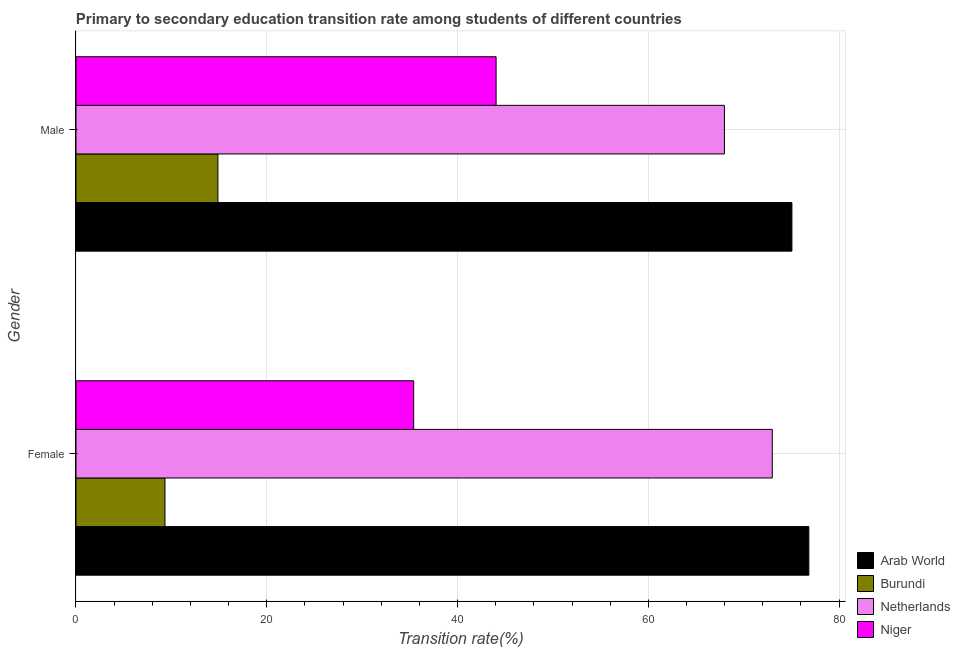Are the number of bars on each tick of the Y-axis equal?
Make the answer very short. Yes. What is the transition rate among male students in Niger?
Your answer should be very brief. 44.04. Across all countries, what is the maximum transition rate among female students?
Provide a short and direct response. 76.83. Across all countries, what is the minimum transition rate among male students?
Ensure brevity in your answer.  14.88. In which country was the transition rate among female students maximum?
Provide a short and direct response. Arab World. In which country was the transition rate among female students minimum?
Offer a very short reply. Burundi. What is the total transition rate among female students in the graph?
Offer a very short reply. 194.55. What is the difference between the transition rate among female students in Arab World and that in Netherlands?
Ensure brevity in your answer.  3.83. What is the difference between the transition rate among male students in Netherlands and the transition rate among female students in Burundi?
Your response must be concise. 58.65. What is the average transition rate among male students per country?
Provide a short and direct response. 50.49. What is the difference between the transition rate among male students and transition rate among female students in Niger?
Ensure brevity in your answer.  8.64. In how many countries, is the transition rate among male students greater than 44 %?
Make the answer very short. 3. What is the ratio of the transition rate among female students in Arab World to that in Netherlands?
Keep it short and to the point. 1.05. What does the 3rd bar from the top in Female represents?
Your answer should be very brief. Burundi. Are all the bars in the graph horizontal?
Give a very brief answer. Yes. How many countries are there in the graph?
Your answer should be very brief. 4. What is the difference between two consecutive major ticks on the X-axis?
Offer a terse response. 20. Does the graph contain grids?
Give a very brief answer. Yes. Where does the legend appear in the graph?
Provide a short and direct response. Bottom right. How many legend labels are there?
Your answer should be compact. 4. How are the legend labels stacked?
Provide a succinct answer. Vertical. What is the title of the graph?
Provide a succinct answer. Primary to secondary education transition rate among students of different countries. Does "Malta" appear as one of the legend labels in the graph?
Your response must be concise. No. What is the label or title of the X-axis?
Your response must be concise. Transition rate(%). What is the Transition rate(%) of Arab World in Female?
Offer a terse response. 76.83. What is the Transition rate(%) of Burundi in Female?
Keep it short and to the point. 9.33. What is the Transition rate(%) of Netherlands in Female?
Keep it short and to the point. 73. What is the Transition rate(%) in Niger in Female?
Your answer should be compact. 35.4. What is the Transition rate(%) of Arab World in Male?
Your response must be concise. 75.05. What is the Transition rate(%) of Burundi in Male?
Provide a short and direct response. 14.88. What is the Transition rate(%) in Netherlands in Male?
Your response must be concise. 67.98. What is the Transition rate(%) in Niger in Male?
Your response must be concise. 44.04. Across all Gender, what is the maximum Transition rate(%) of Arab World?
Offer a terse response. 76.83. Across all Gender, what is the maximum Transition rate(%) in Burundi?
Your answer should be very brief. 14.88. Across all Gender, what is the maximum Transition rate(%) in Netherlands?
Your answer should be compact. 73. Across all Gender, what is the maximum Transition rate(%) of Niger?
Offer a very short reply. 44.04. Across all Gender, what is the minimum Transition rate(%) of Arab World?
Offer a terse response. 75.05. Across all Gender, what is the minimum Transition rate(%) of Burundi?
Your response must be concise. 9.33. Across all Gender, what is the minimum Transition rate(%) in Netherlands?
Offer a terse response. 67.98. Across all Gender, what is the minimum Transition rate(%) in Niger?
Your answer should be compact. 35.4. What is the total Transition rate(%) of Arab World in the graph?
Ensure brevity in your answer.  151.88. What is the total Transition rate(%) in Burundi in the graph?
Make the answer very short. 24.21. What is the total Transition rate(%) in Netherlands in the graph?
Your response must be concise. 140.97. What is the total Transition rate(%) of Niger in the graph?
Provide a succinct answer. 79.44. What is the difference between the Transition rate(%) of Arab World in Female and that in Male?
Offer a terse response. 1.78. What is the difference between the Transition rate(%) of Burundi in Female and that in Male?
Keep it short and to the point. -5.55. What is the difference between the Transition rate(%) of Netherlands in Female and that in Male?
Your response must be concise. 5.02. What is the difference between the Transition rate(%) of Niger in Female and that in Male?
Offer a very short reply. -8.64. What is the difference between the Transition rate(%) in Arab World in Female and the Transition rate(%) in Burundi in Male?
Your response must be concise. 61.95. What is the difference between the Transition rate(%) of Arab World in Female and the Transition rate(%) of Netherlands in Male?
Offer a very short reply. 8.85. What is the difference between the Transition rate(%) of Arab World in Female and the Transition rate(%) of Niger in Male?
Your response must be concise. 32.79. What is the difference between the Transition rate(%) in Burundi in Female and the Transition rate(%) in Netherlands in Male?
Your answer should be very brief. -58.65. What is the difference between the Transition rate(%) in Burundi in Female and the Transition rate(%) in Niger in Male?
Provide a short and direct response. -34.71. What is the difference between the Transition rate(%) in Netherlands in Female and the Transition rate(%) in Niger in Male?
Ensure brevity in your answer.  28.95. What is the average Transition rate(%) in Arab World per Gender?
Offer a very short reply. 75.94. What is the average Transition rate(%) in Burundi per Gender?
Your response must be concise. 12.1. What is the average Transition rate(%) of Netherlands per Gender?
Offer a terse response. 70.49. What is the average Transition rate(%) of Niger per Gender?
Your answer should be compact. 39.72. What is the difference between the Transition rate(%) in Arab World and Transition rate(%) in Burundi in Female?
Give a very brief answer. 67.5. What is the difference between the Transition rate(%) in Arab World and Transition rate(%) in Netherlands in Female?
Your response must be concise. 3.83. What is the difference between the Transition rate(%) of Arab World and Transition rate(%) of Niger in Female?
Keep it short and to the point. 41.43. What is the difference between the Transition rate(%) in Burundi and Transition rate(%) in Netherlands in Female?
Offer a very short reply. -63.67. What is the difference between the Transition rate(%) of Burundi and Transition rate(%) of Niger in Female?
Provide a short and direct response. -26.07. What is the difference between the Transition rate(%) in Netherlands and Transition rate(%) in Niger in Female?
Your answer should be very brief. 37.59. What is the difference between the Transition rate(%) in Arab World and Transition rate(%) in Burundi in Male?
Keep it short and to the point. 60.17. What is the difference between the Transition rate(%) of Arab World and Transition rate(%) of Netherlands in Male?
Give a very brief answer. 7.08. What is the difference between the Transition rate(%) in Arab World and Transition rate(%) in Niger in Male?
Offer a terse response. 31.01. What is the difference between the Transition rate(%) in Burundi and Transition rate(%) in Netherlands in Male?
Keep it short and to the point. -53.1. What is the difference between the Transition rate(%) in Burundi and Transition rate(%) in Niger in Male?
Make the answer very short. -29.16. What is the difference between the Transition rate(%) of Netherlands and Transition rate(%) of Niger in Male?
Your response must be concise. 23.94. What is the ratio of the Transition rate(%) in Arab World in Female to that in Male?
Your answer should be very brief. 1.02. What is the ratio of the Transition rate(%) of Burundi in Female to that in Male?
Offer a terse response. 0.63. What is the ratio of the Transition rate(%) of Netherlands in Female to that in Male?
Provide a succinct answer. 1.07. What is the ratio of the Transition rate(%) in Niger in Female to that in Male?
Your answer should be very brief. 0.8. What is the difference between the highest and the second highest Transition rate(%) of Arab World?
Keep it short and to the point. 1.78. What is the difference between the highest and the second highest Transition rate(%) of Burundi?
Give a very brief answer. 5.55. What is the difference between the highest and the second highest Transition rate(%) of Netherlands?
Provide a succinct answer. 5.02. What is the difference between the highest and the second highest Transition rate(%) of Niger?
Keep it short and to the point. 8.64. What is the difference between the highest and the lowest Transition rate(%) in Arab World?
Ensure brevity in your answer.  1.78. What is the difference between the highest and the lowest Transition rate(%) in Burundi?
Your answer should be compact. 5.55. What is the difference between the highest and the lowest Transition rate(%) in Netherlands?
Provide a succinct answer. 5.02. What is the difference between the highest and the lowest Transition rate(%) in Niger?
Offer a very short reply. 8.64. 